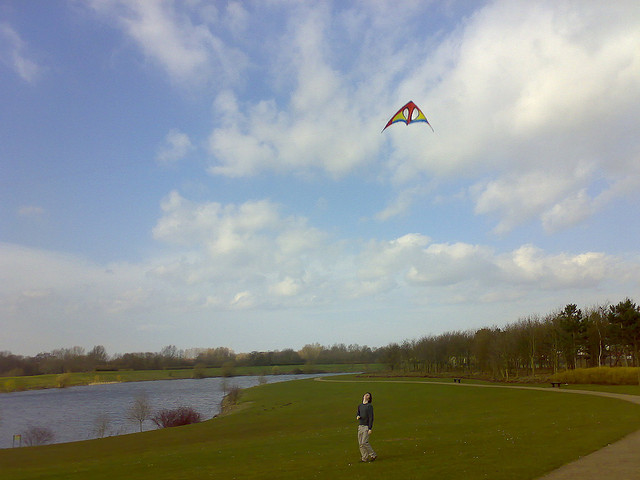How many little girls can be seen? There are no little girls present in the image. The image features an open grassy area by a body of water with a single person flying a colorful kite. 